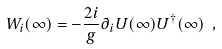Convert formula to latex. <formula><loc_0><loc_0><loc_500><loc_500>W _ { i } ( \infty ) = - \frac { 2 i } { g } \partial _ { i } U ( \infty ) U ^ { \dagger } ( \infty ) \ ,</formula> 